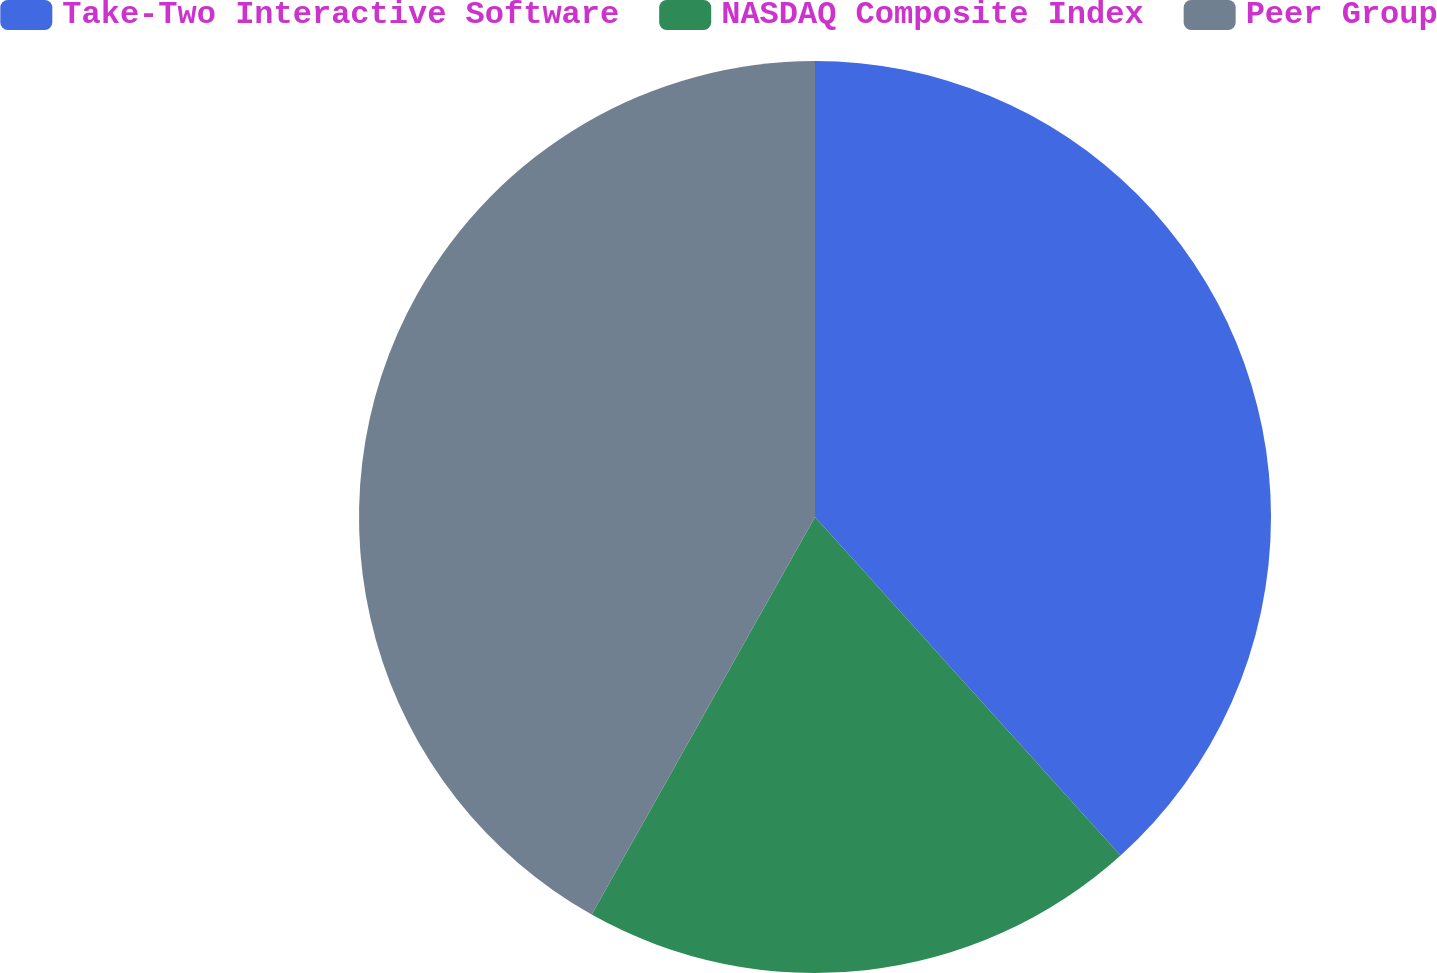Convert chart. <chart><loc_0><loc_0><loc_500><loc_500><pie_chart><fcel>Take-Two Interactive Software<fcel>NASDAQ Composite Index<fcel>Peer Group<nl><fcel>38.31%<fcel>19.83%<fcel>41.85%<nl></chart> 